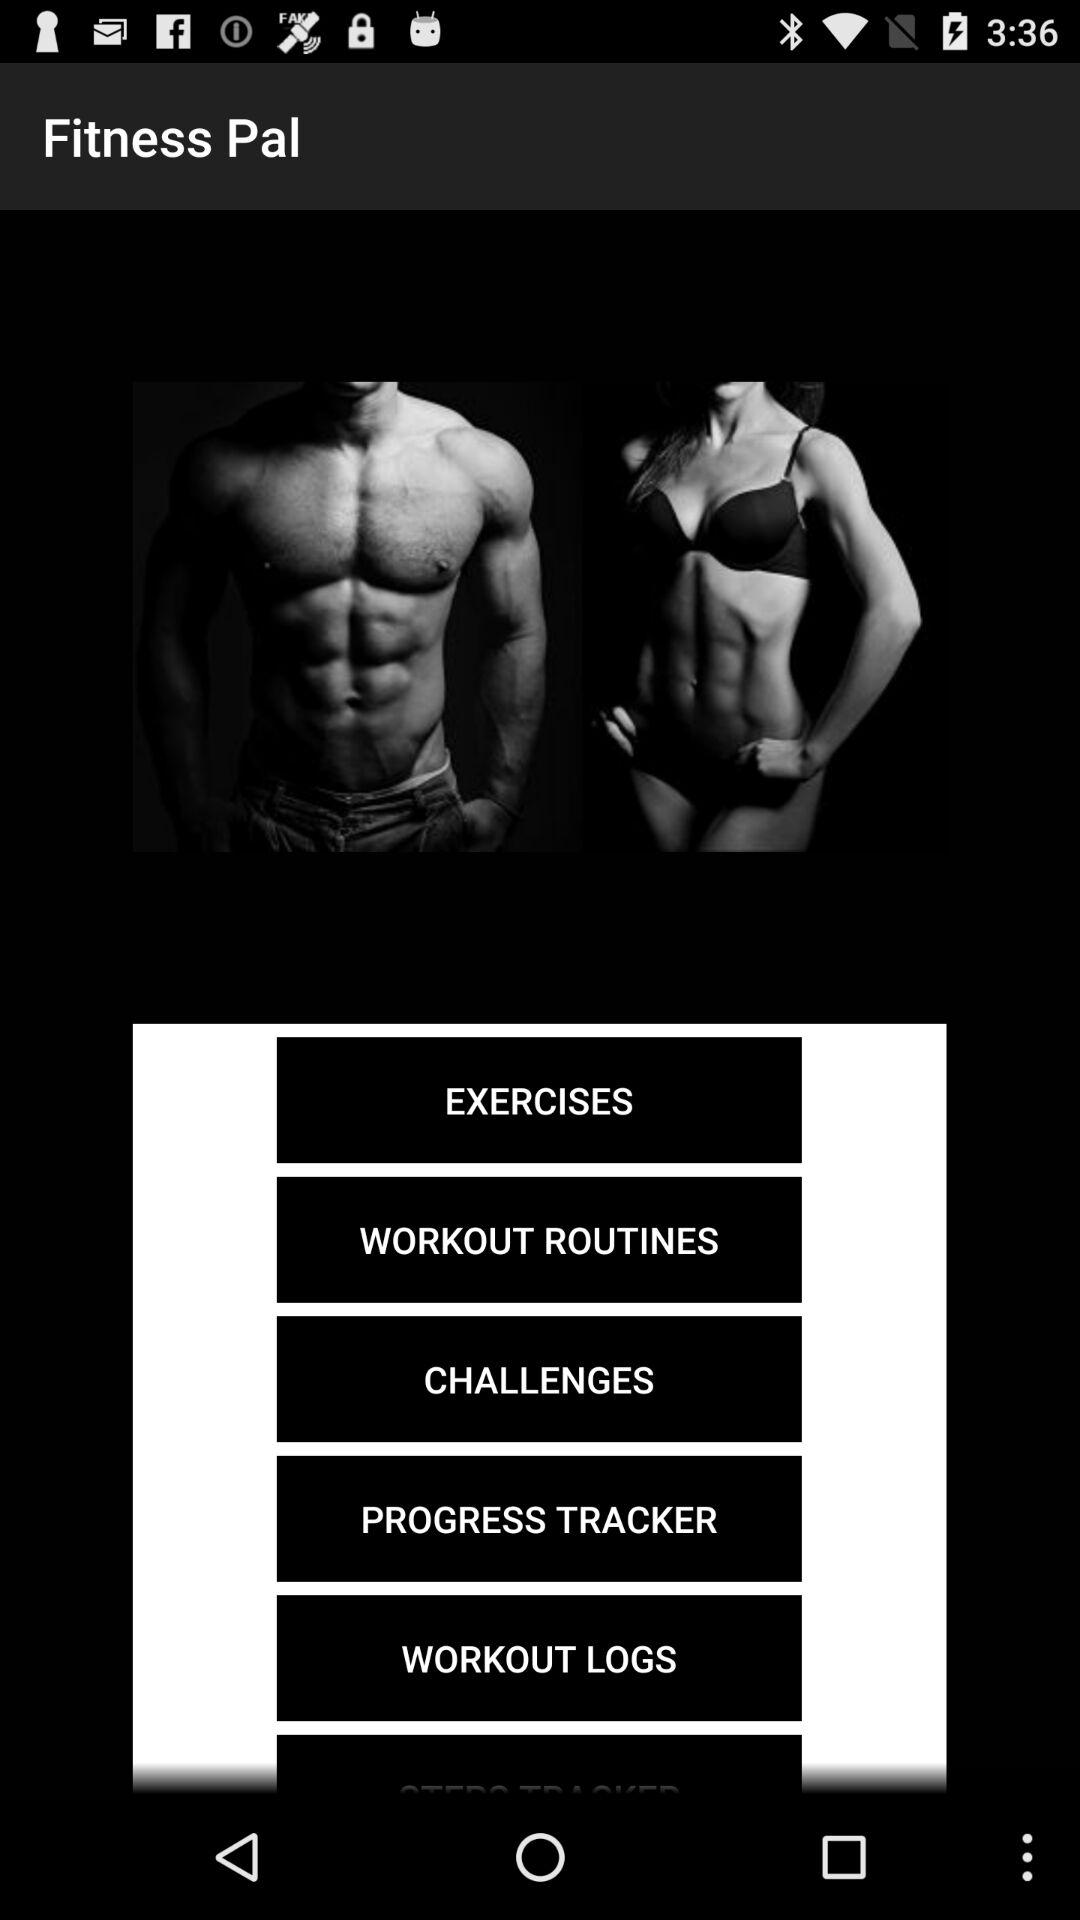What is the name of the application? The name of the application is "Fitness Pal". 